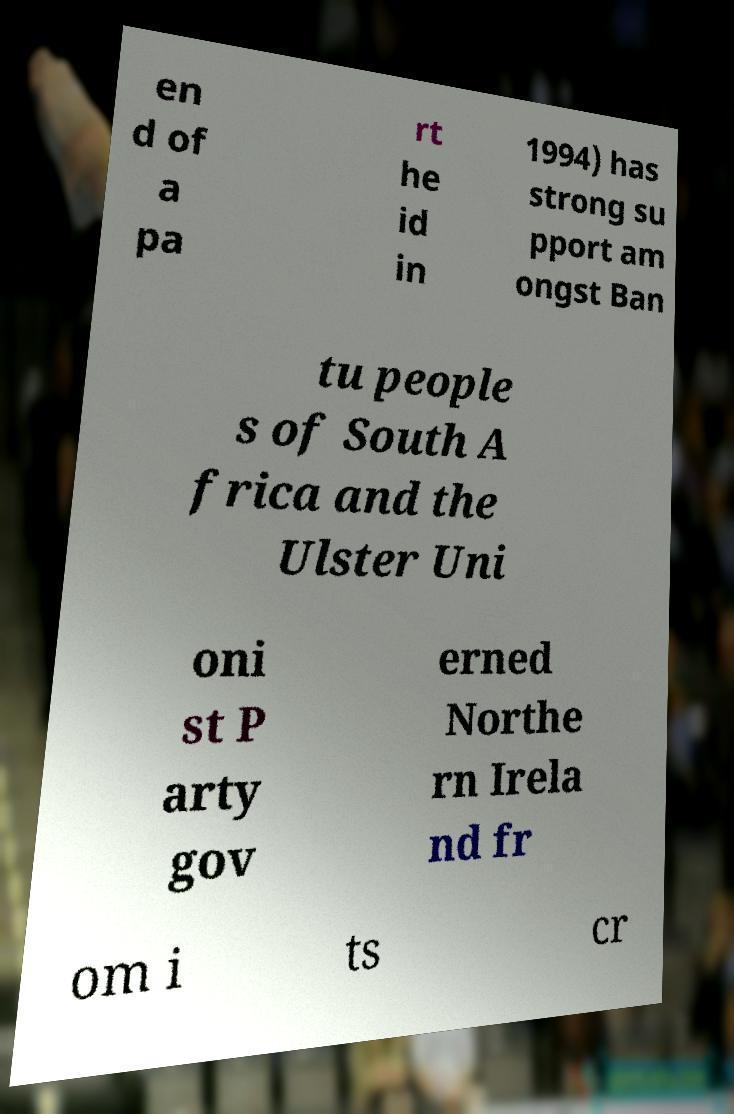For documentation purposes, I need the text within this image transcribed. Could you provide that? en d of a pa rt he id in 1994) has strong su pport am ongst Ban tu people s of South A frica and the Ulster Uni oni st P arty gov erned Northe rn Irela nd fr om i ts cr 